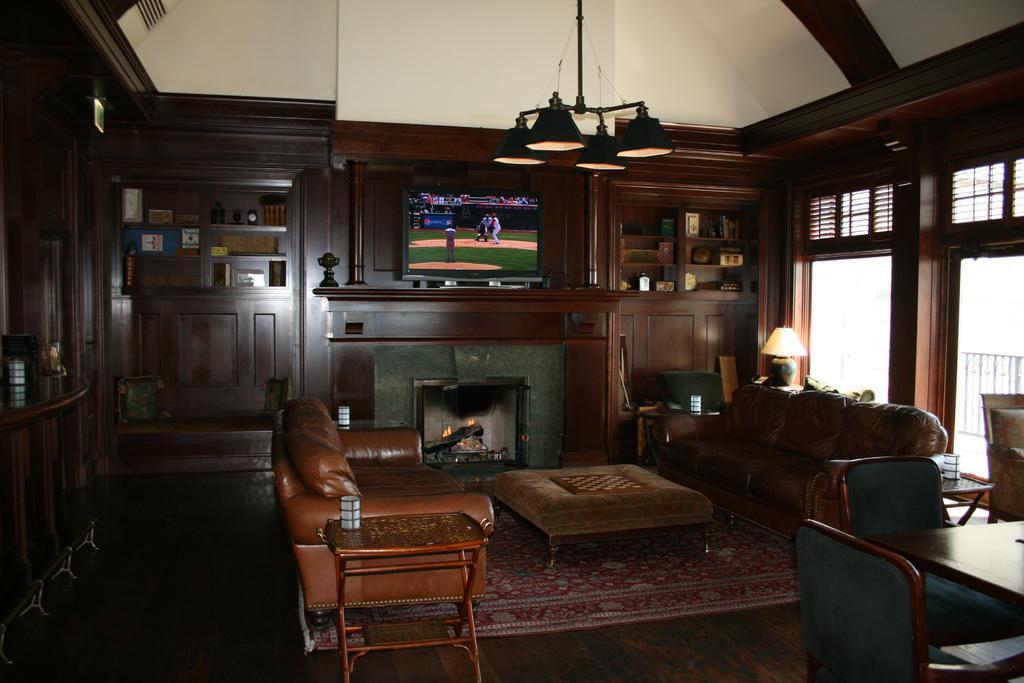How would you summarize this image in a sentence or two? This picture is taken in the room, In the middle there is a sofa which is in brown color and there is a table in brown color and in the background there is a television and there are some wooden blocks in brown color. 